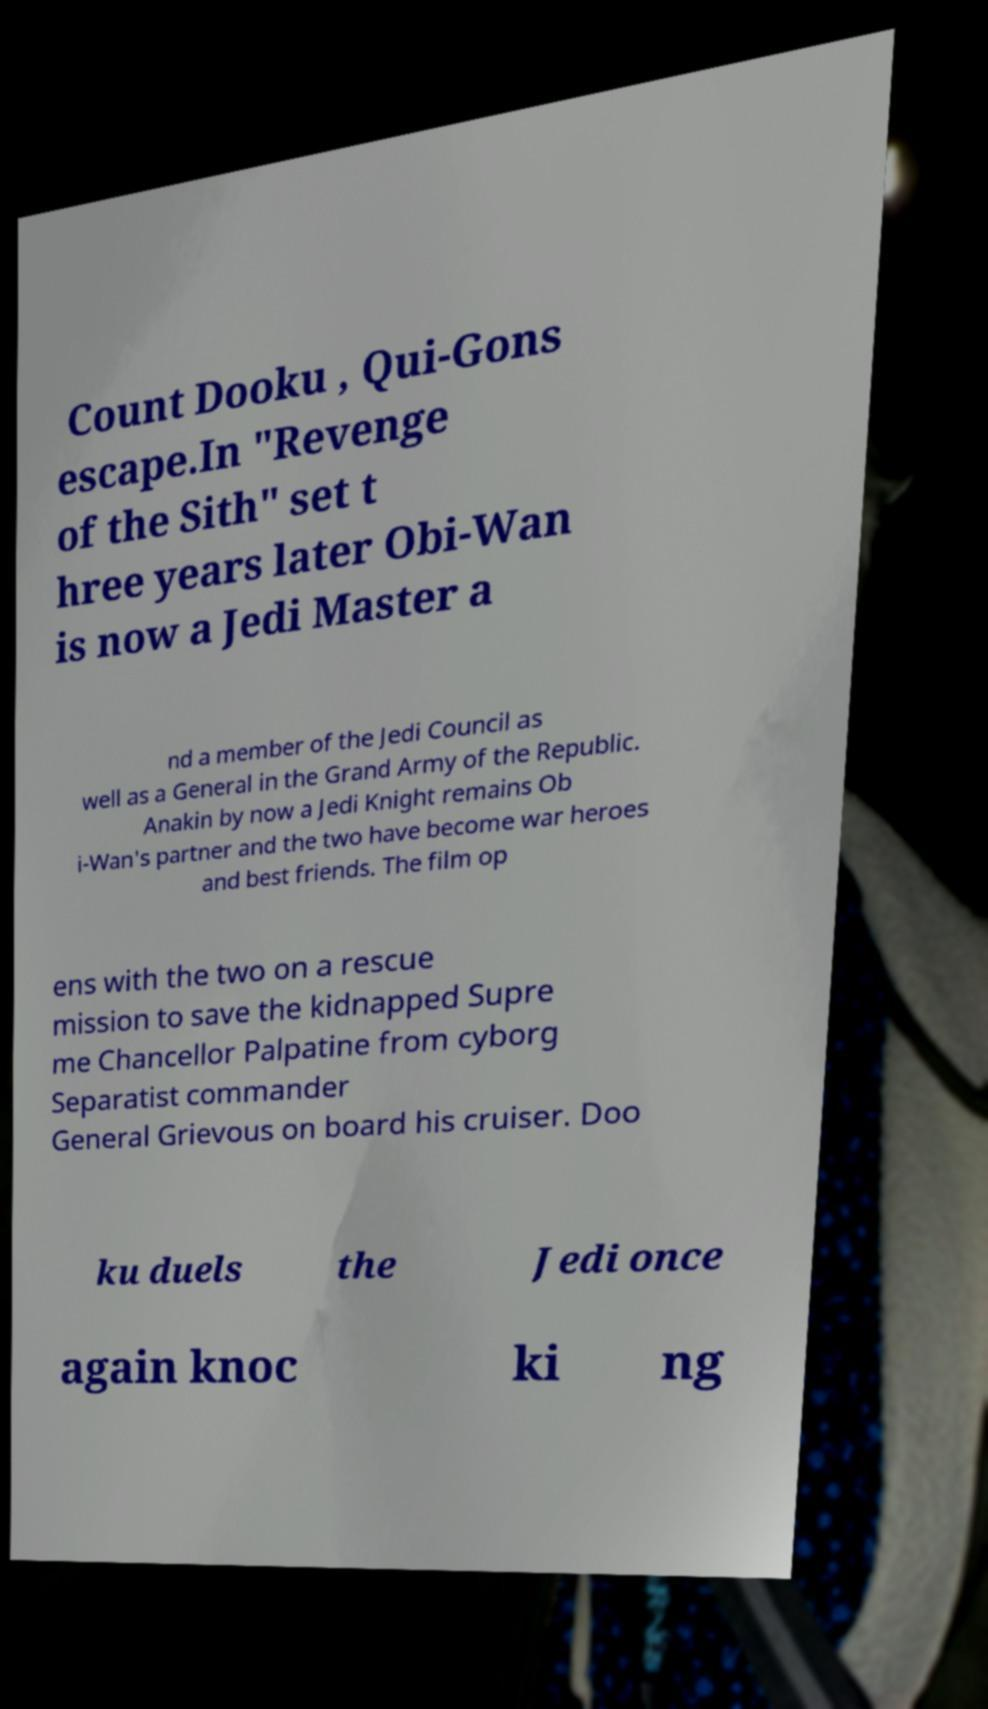Can you read and provide the text displayed in the image?This photo seems to have some interesting text. Can you extract and type it out for me? Count Dooku , Qui-Gons escape.In "Revenge of the Sith" set t hree years later Obi-Wan is now a Jedi Master a nd a member of the Jedi Council as well as a General in the Grand Army of the Republic. Anakin by now a Jedi Knight remains Ob i-Wan's partner and the two have become war heroes and best friends. The film op ens with the two on a rescue mission to save the kidnapped Supre me Chancellor Palpatine from cyborg Separatist commander General Grievous on board his cruiser. Doo ku duels the Jedi once again knoc ki ng 